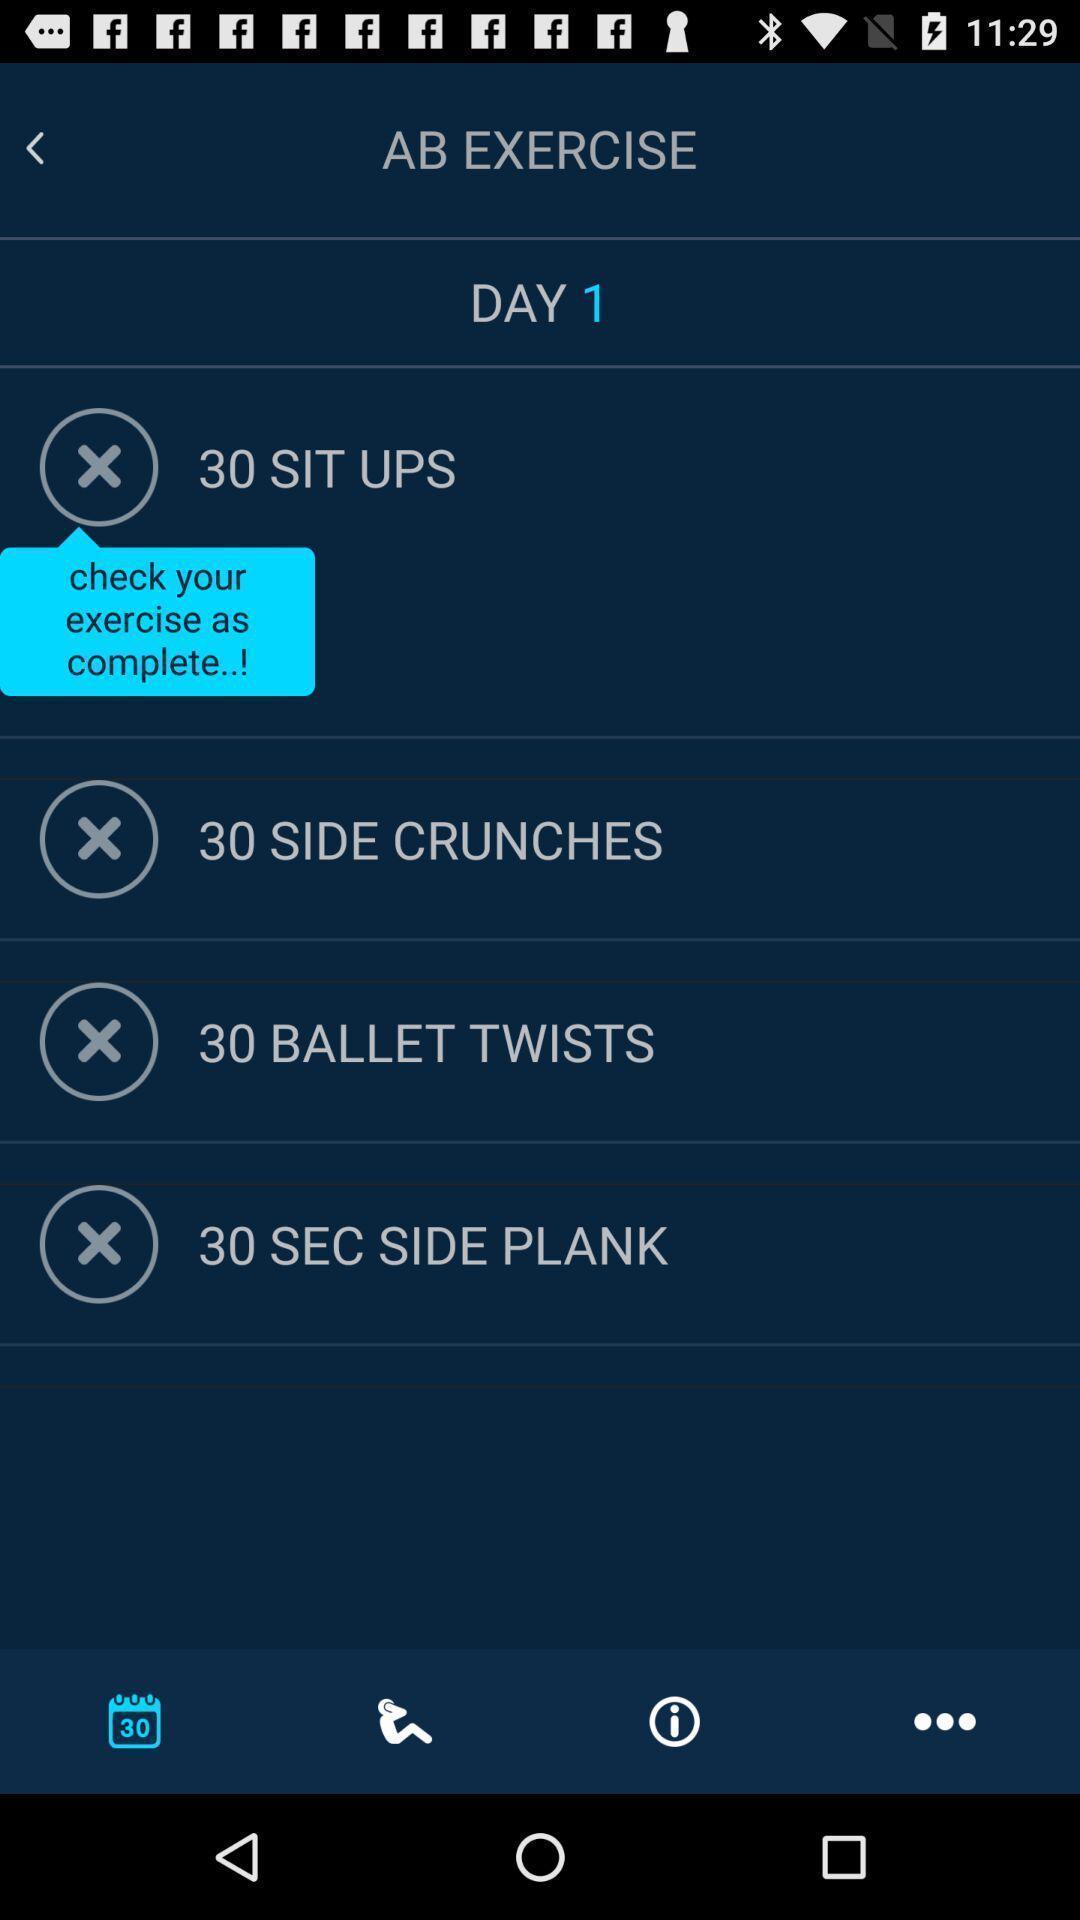Give me a summary of this screen capture. Page displaying various exercises in fitness application. 